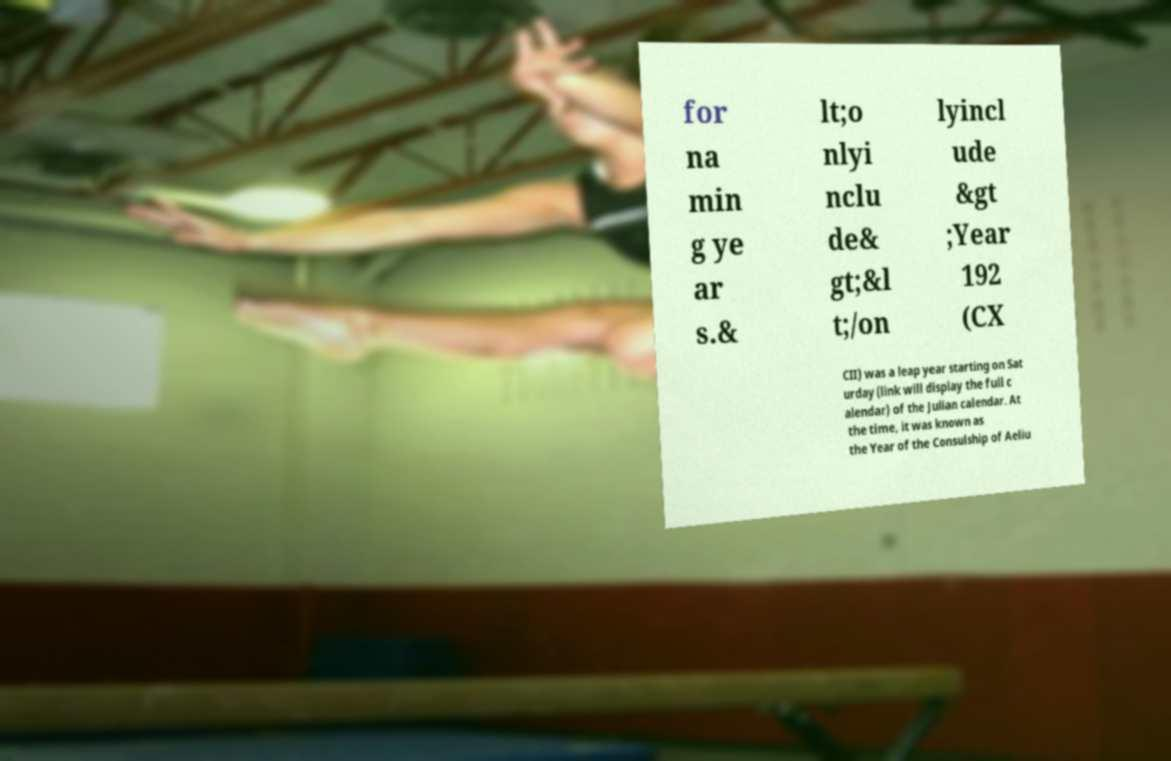What messages or text are displayed in this image? I need them in a readable, typed format. for na min g ye ar s.& lt;o nlyi nclu de& gt;&l t;/on lyincl ude &gt ;Year 192 (CX CII) was a leap year starting on Sat urday (link will display the full c alendar) of the Julian calendar. At the time, it was known as the Year of the Consulship of Aeliu 